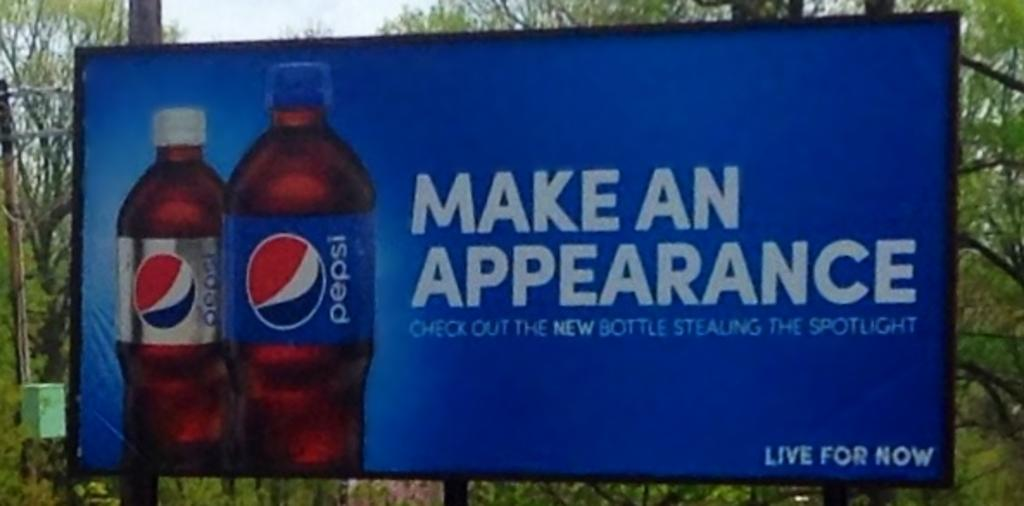<image>
Present a compact description of the photo's key features. An ad for Pepsi reads Live For Now 